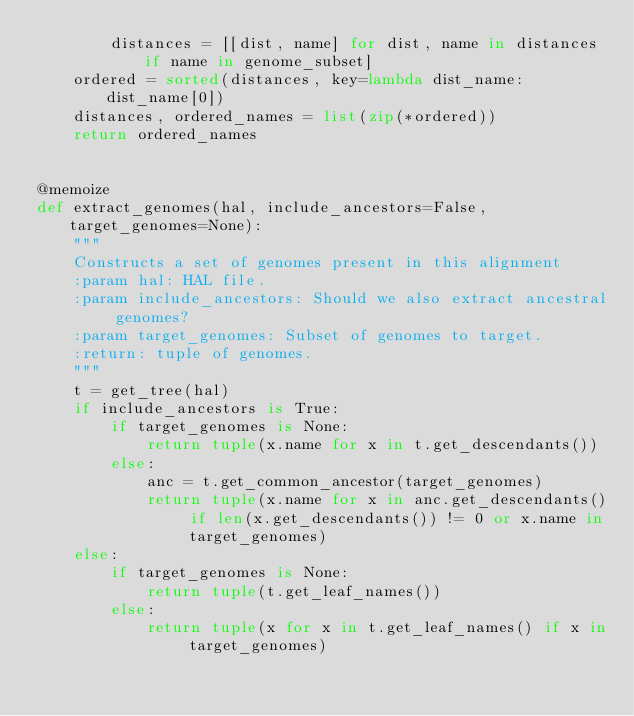Convert code to text. <code><loc_0><loc_0><loc_500><loc_500><_Python_>        distances = [[dist, name] for dist, name in distances if name in genome_subset]
    ordered = sorted(distances, key=lambda dist_name: dist_name[0])
    distances, ordered_names = list(zip(*ordered))
    return ordered_names


@memoize
def extract_genomes(hal, include_ancestors=False, target_genomes=None):
    """
    Constructs a set of genomes present in this alignment
    :param hal: HAL file.
    :param include_ancestors: Should we also extract ancestral genomes?
    :param target_genomes: Subset of genomes to target.
    :return: tuple of genomes.
    """
    t = get_tree(hal)
    if include_ancestors is True:
        if target_genomes is None:
            return tuple(x.name for x in t.get_descendants())
        else:
            anc = t.get_common_ancestor(target_genomes)
            return tuple(x.name for x in anc.get_descendants() if len(x.get_descendants()) != 0 or x.name in target_genomes)
    else:
        if target_genomes is None:
            return tuple(t.get_leaf_names())
        else:
            return tuple(x for x in t.get_leaf_names() if x in target_genomes)
</code> 